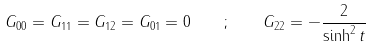Convert formula to latex. <formula><loc_0><loc_0><loc_500><loc_500>G _ { 0 0 } = G _ { 1 1 } = G _ { 1 2 } = G _ { 0 1 } = 0 \quad ; \quad G _ { 2 2 } = - \frac { 2 } { \sinh ^ { 2 } t }</formula> 